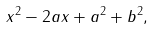Convert formula to latex. <formula><loc_0><loc_0><loc_500><loc_500>x ^ { 2 } - 2 a x + a ^ { 2 } + b ^ { 2 } ,</formula> 